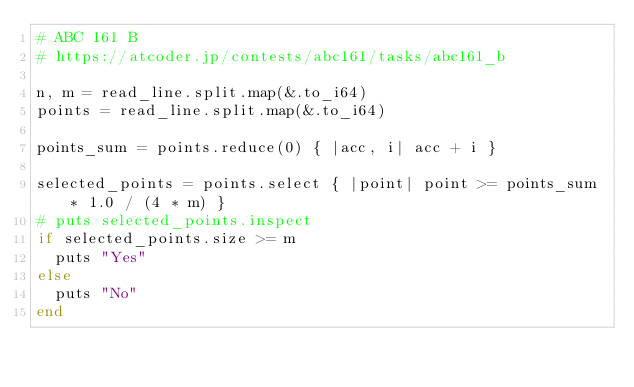Convert code to text. <code><loc_0><loc_0><loc_500><loc_500><_Crystal_># ABC 161 B
# https://atcoder.jp/contests/abc161/tasks/abc161_b

n, m = read_line.split.map(&.to_i64)
points = read_line.split.map(&.to_i64)

points_sum = points.reduce(0) { |acc, i| acc + i }

selected_points = points.select { |point| point >= points_sum * 1.0 / (4 * m) }
# puts selected_points.inspect
if selected_points.size >= m
  puts "Yes"
else
  puts "No"
end
</code> 